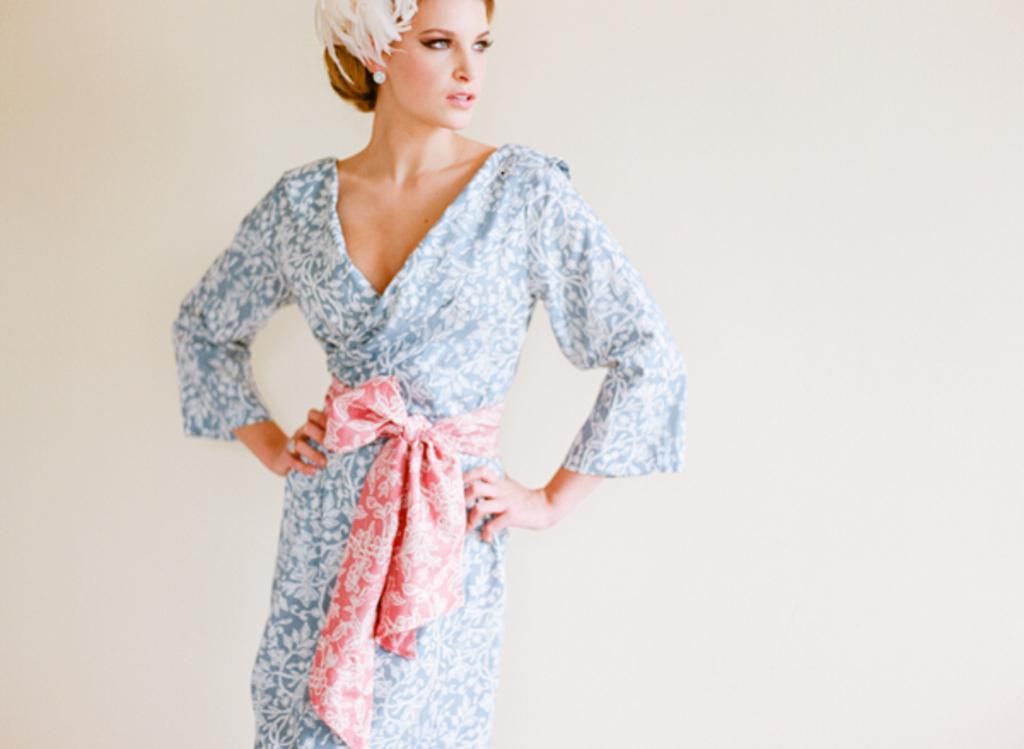Could you give a brief overview of what you see in this image? In this image we can see a woman standing. On the backside we can see a wall. 